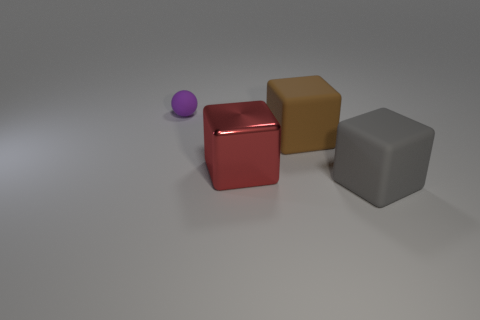What number of other things are there of the same size as the matte sphere?
Ensure brevity in your answer.  0. There is a large rubber object left of the big gray block that is in front of the rubber block behind the big gray block; what color is it?
Offer a very short reply. Brown. There is a matte thing left of the big block that is on the left side of the brown object; how many large rubber things are right of it?
Keep it short and to the point. 2. Is there any other thing of the same color as the rubber sphere?
Your answer should be compact. No. Do the rubber cube that is in front of the red block and the brown matte cube have the same size?
Provide a succinct answer. Yes. How many large gray cubes are behind the large matte block in front of the red cube?
Keep it short and to the point. 0. Is there a large matte object that is on the right side of the matte block in front of the large brown rubber cube behind the big red block?
Your answer should be very brief. No. What material is the red object that is the same shape as the brown matte object?
Give a very brief answer. Metal. Is there anything else that has the same material as the big red object?
Provide a short and direct response. No. Does the big brown cube have the same material as the object that is to the left of the large red thing?
Keep it short and to the point. Yes. 